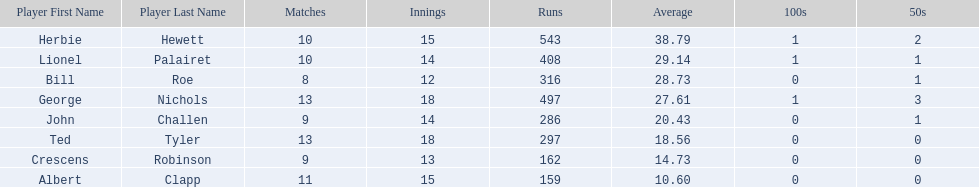Who are the players in somerset county cricket club in 1890? Herbie Hewett, Lionel Palairet, Bill Roe, George Nichols, John Challen, Ted Tyler, Crescens Robinson, Albert Clapp. Who is the only player to play less than 13 innings? Bill Roe. 